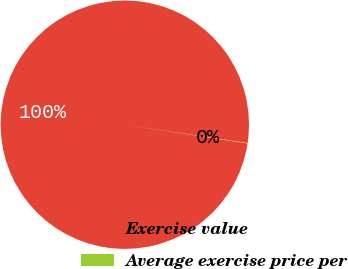<chart> <loc_0><loc_0><loc_500><loc_500><pie_chart><fcel>Exercise value<fcel>Average exercise price per<nl><fcel>99.95%<fcel>0.05%<nl></chart> 